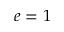Convert formula to latex. <formula><loc_0><loc_0><loc_500><loc_500>e = 1</formula> 